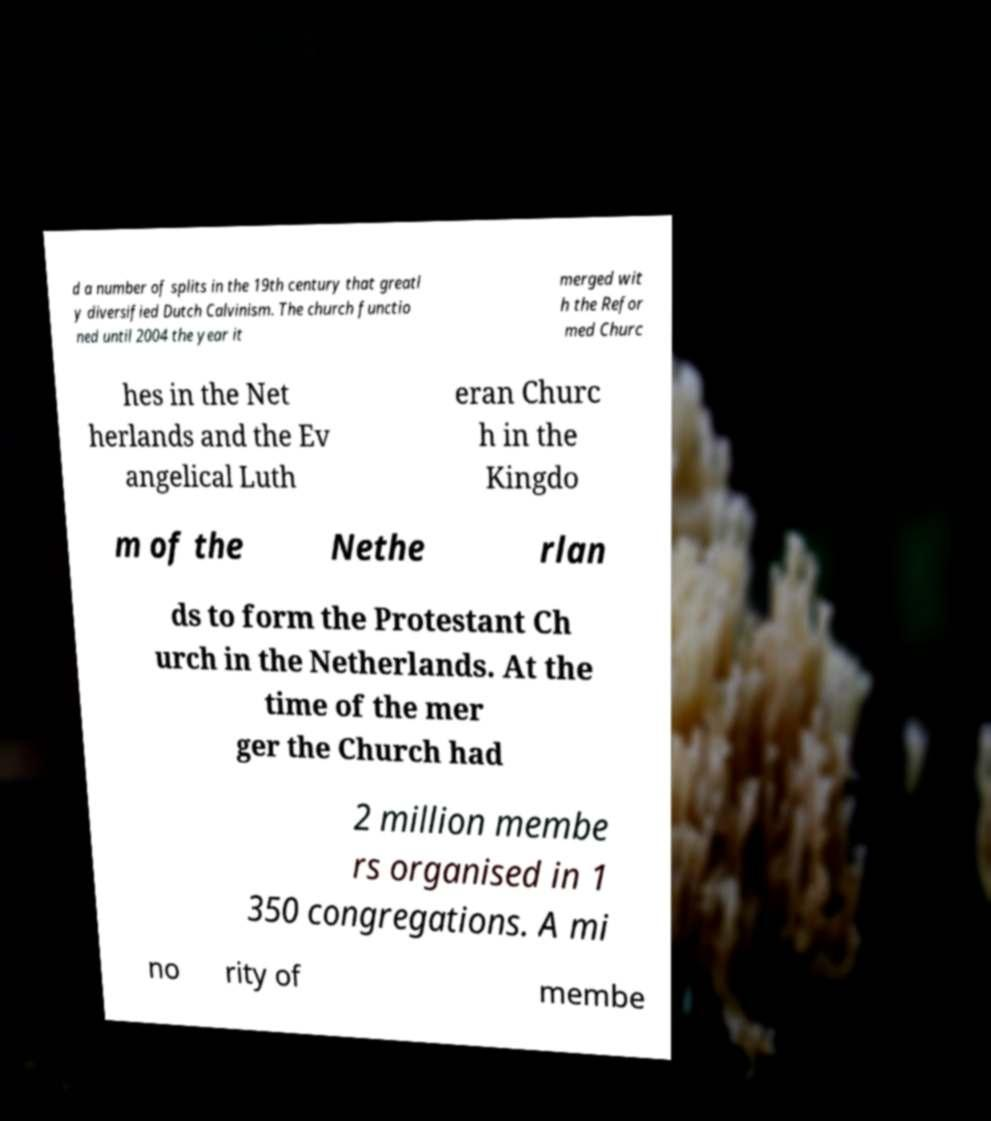There's text embedded in this image that I need extracted. Can you transcribe it verbatim? d a number of splits in the 19th century that greatl y diversified Dutch Calvinism. The church functio ned until 2004 the year it merged wit h the Refor med Churc hes in the Net herlands and the Ev angelical Luth eran Churc h in the Kingdo m of the Nethe rlan ds to form the Protestant Ch urch in the Netherlands. At the time of the mer ger the Church had 2 million membe rs organised in 1 350 congregations. A mi no rity of membe 